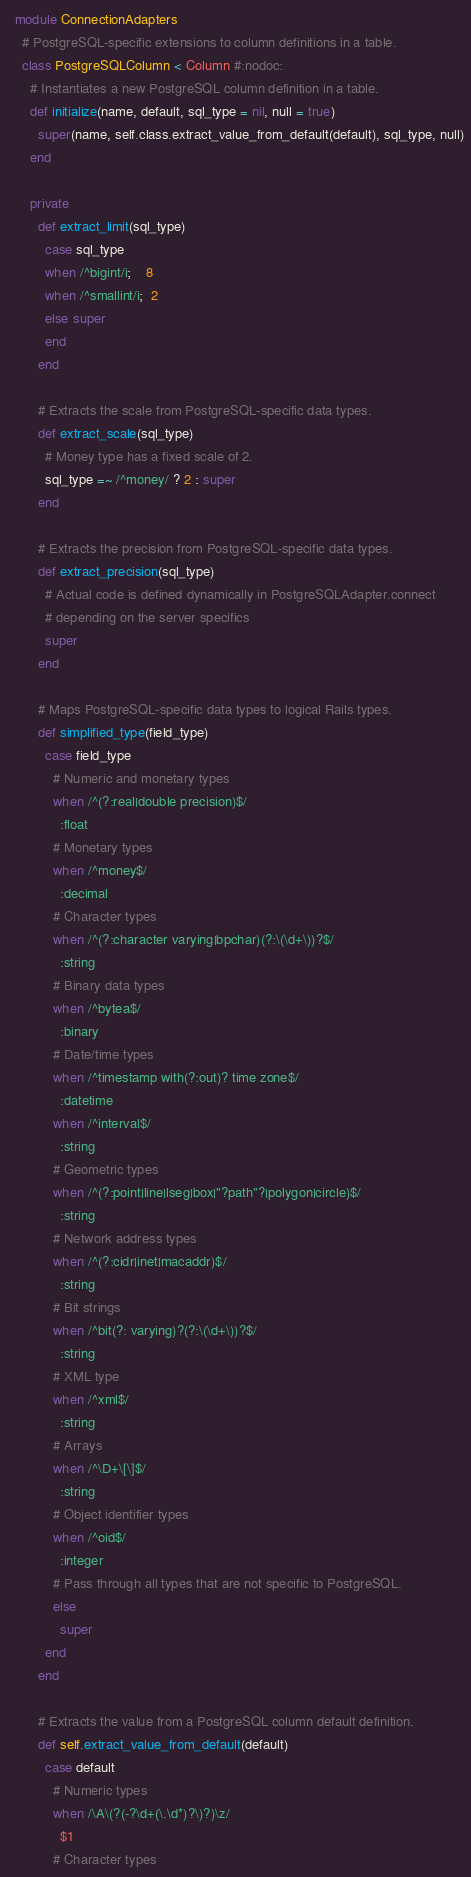<code> <loc_0><loc_0><loc_500><loc_500><_Ruby_>
  module ConnectionAdapters
    # PostgreSQL-specific extensions to column definitions in a table.
    class PostgreSQLColumn < Column #:nodoc:
      # Instantiates a new PostgreSQL column definition in a table.
      def initialize(name, default, sql_type = nil, null = true)
        super(name, self.class.extract_value_from_default(default), sql_type, null)
      end

      private
        def extract_limit(sql_type)
          case sql_type
          when /^bigint/i;    8
          when /^smallint/i;  2
          else super
          end
        end

        # Extracts the scale from PostgreSQL-specific data types.
        def extract_scale(sql_type)
          # Money type has a fixed scale of 2.
          sql_type =~ /^money/ ? 2 : super
        end

        # Extracts the precision from PostgreSQL-specific data types.
        def extract_precision(sql_type)
          # Actual code is defined dynamically in PostgreSQLAdapter.connect
          # depending on the server specifics
          super
        end
  
        # Maps PostgreSQL-specific data types to logical Rails types.
        def simplified_type(field_type)
          case field_type
            # Numeric and monetary types
            when /^(?:real|double precision)$/
              :float
            # Monetary types
            when /^money$/
              :decimal
            # Character types
            when /^(?:character varying|bpchar)(?:\(\d+\))?$/
              :string
            # Binary data types
            when /^bytea$/
              :binary
            # Date/time types
            when /^timestamp with(?:out)? time zone$/
              :datetime
            when /^interval$/
              :string
            # Geometric types
            when /^(?:point|line|lseg|box|"?path"?|polygon|circle)$/
              :string
            # Network address types
            when /^(?:cidr|inet|macaddr)$/
              :string
            # Bit strings
            when /^bit(?: varying)?(?:\(\d+\))?$/
              :string
            # XML type
            when /^xml$/
              :string
            # Arrays
            when /^\D+\[\]$/
              :string              
            # Object identifier types
            when /^oid$/
              :integer
            # Pass through all types that are not specific to PostgreSQL.
            else
              super
          end
        end
  
        # Extracts the value from a PostgreSQL column default definition.
        def self.extract_value_from_default(default)
          case default
            # Numeric types
            when /\A\(?(-?\d+(\.\d*)?\)?)\z/
              $1
            # Character types</code> 